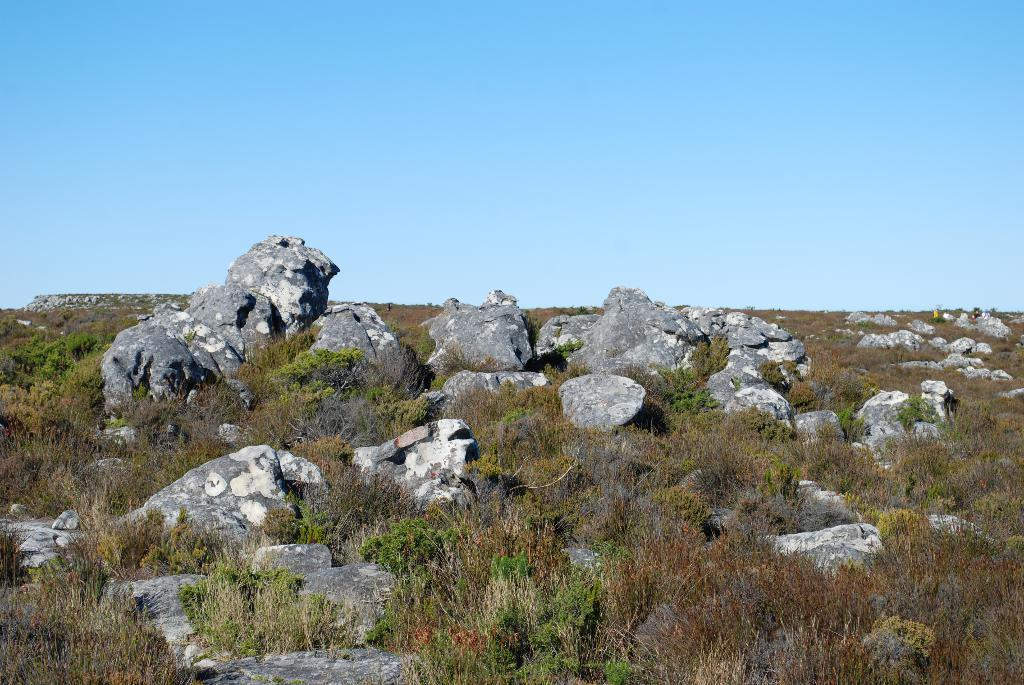What type of natural elements can be seen in the image? There are rocks and plants in the image. Can you describe the rocks in the image? The rocks in the image are likely part of a landscape or natural setting. What type of plants are visible in the image? The plants in the image could be various types, such as trees, bushes, or flowers. How many parcels can be seen in the image? There are no parcels present in the image; it features rocks and plants. What type of square structure is visible in the image? There is no square structure present in the image; it only contains rocks and plants. 